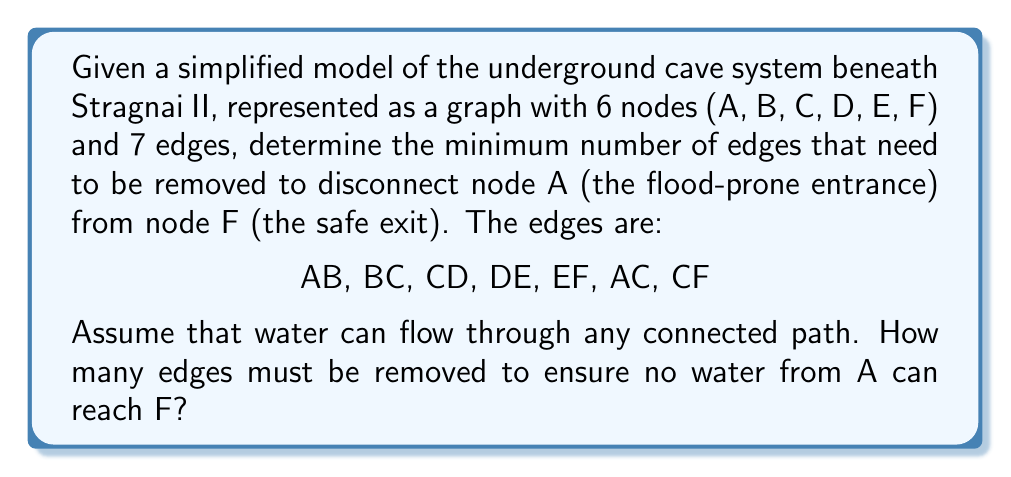Could you help me with this problem? To solve this problem, we need to use the concept of edge connectivity in graph theory, which is closely related to the Max-Flow Min-Cut theorem.

Step 1: Visualize the graph
Let's first visualize the graph:

[asy]
unitsize(1cm);

pair A = (0,0), B = (2,1), C = (1,2), D = (3,2), E = (4,1), F = (5,0);

draw(A--B--C--D--E--F);
draw(A--C--F);

dot("A", A, SW);
dot("B", B, S);
dot("C", C, N);
dot("D", D, N);
dot("E", E, N);
dot("F", F, SE);
[/asy]

Step 2: Identify all possible paths from A to F
1. A-B-C-D-E-F
2. A-C-D-E-F
3. A-C-F

Step 3: Apply Max-Flow Min-Cut theorem
The minimum number of edges to be removed is equal to the maximum number of edge-disjoint paths from A to F.

Step 4: Find edge-disjoint paths
We can identify the following edge-disjoint paths:
1. A-C-F
2. A-B-C-D-E-F

These two paths do not share any edges.

Step 5: Verify no more edge-disjoint paths exist
We cannot find a third path that doesn't share edges with the two paths above.

Therefore, the maximum number of edge-disjoint paths is 2.

Step 6: Conclude
According to the Max-Flow Min-Cut theorem, we need to remove 2 edges to disconnect A from F.

This could be achieved by removing edges AC and CF, or by removing AB and DE, for example.
Answer: The minimum number of edges that need to be removed to disconnect node A from node F is 2. 